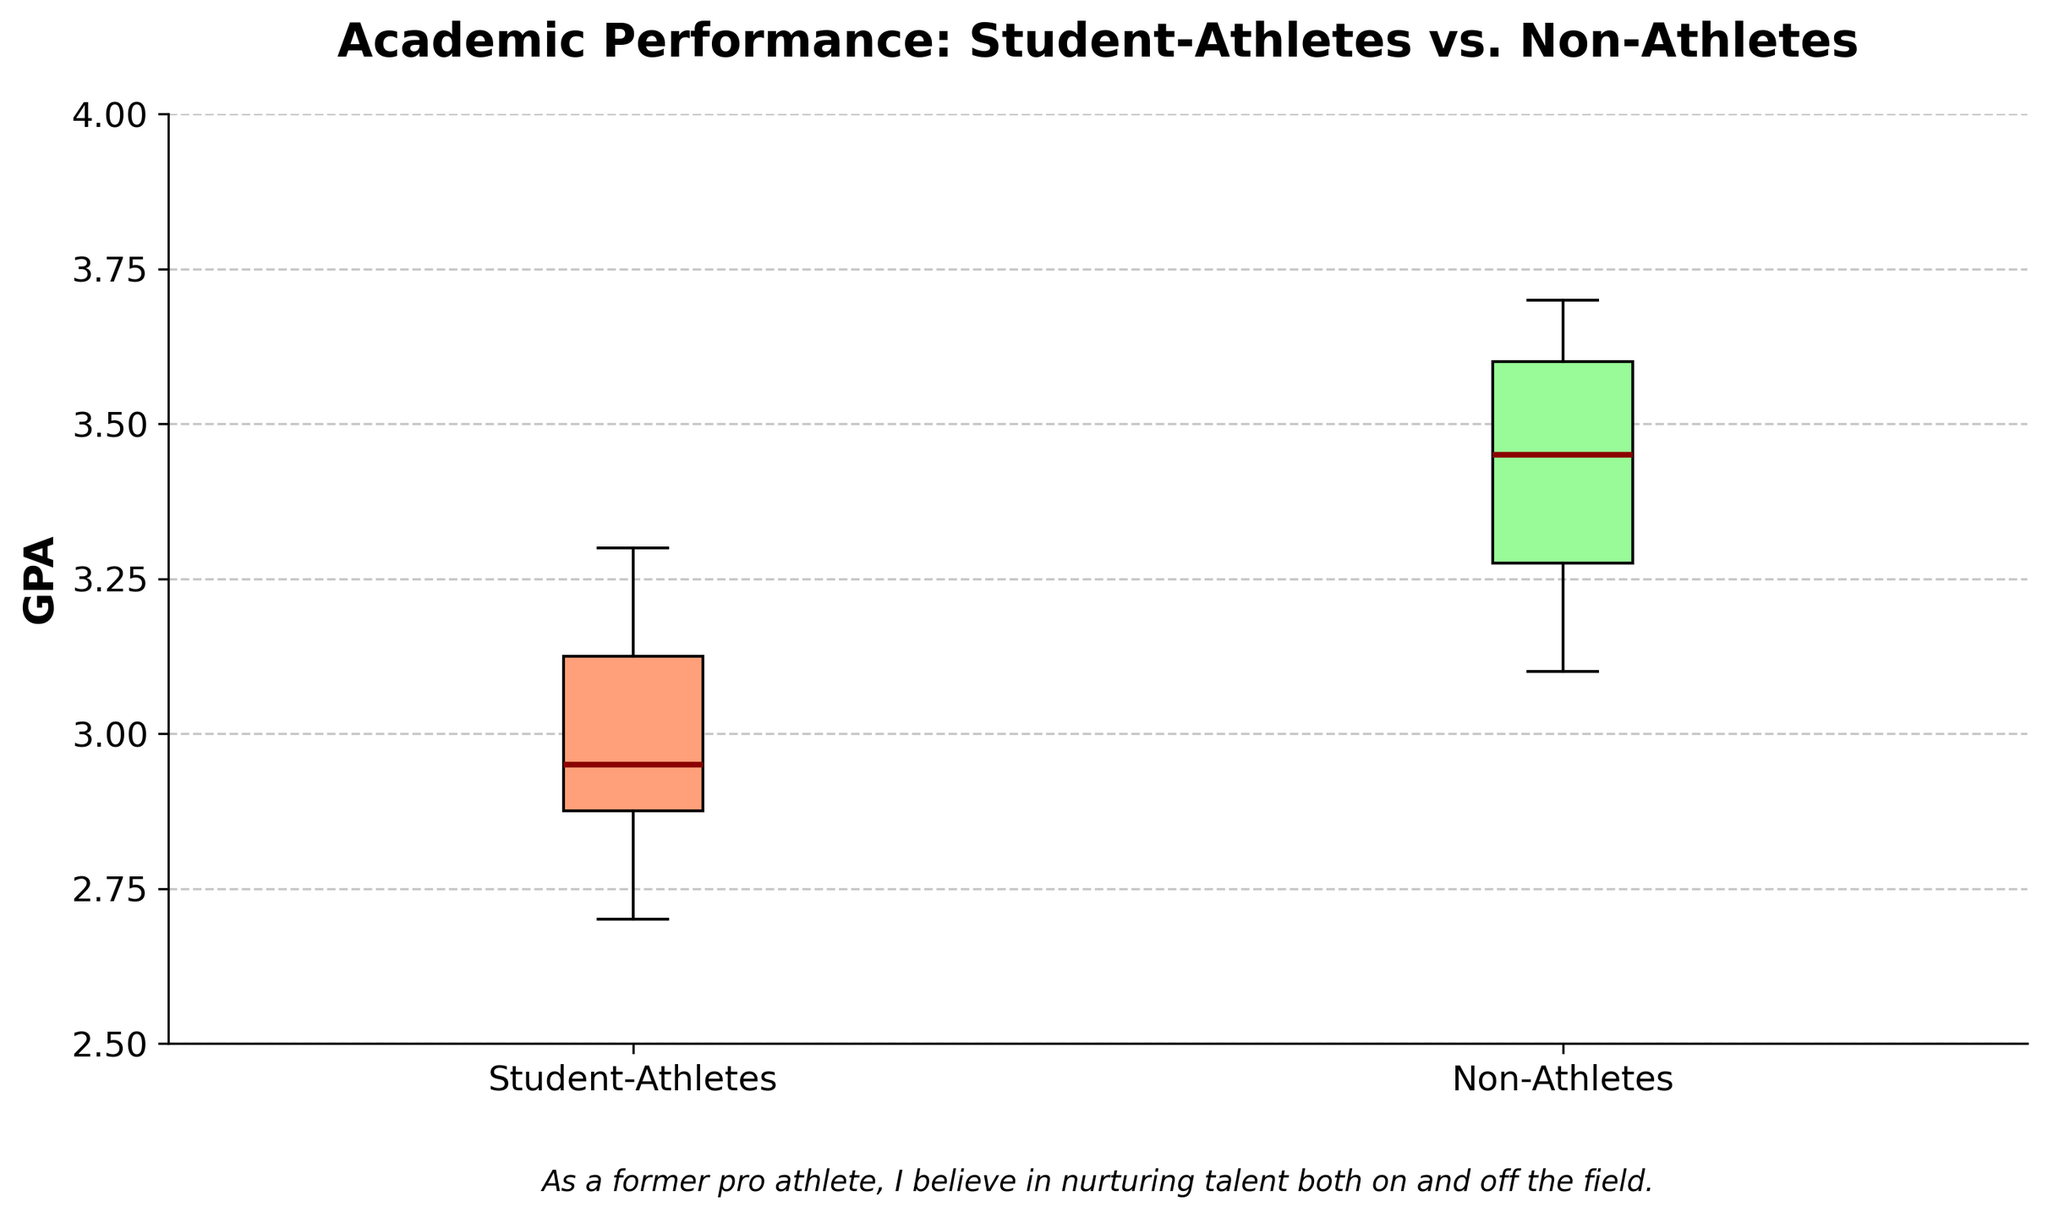What's the title of the figure? The title of the figure is prominently displayed at the top in bold.
Answer: Academic Performance: Student-Athletes vs. Non-Athletes What is the y-axis representing in the figure? The y-axis label, placed vertically, states that it represents the GPA (Grade Point Average).
Answer: GPA What are the median GPA values for each group? The median values are depicted by the dark red lines within the boxes. For Student-Athletes, the median line is around 2.9, while for Non-Athletes, it is around 3.45.
Answer: Approximately 2.9 for Student-Athletes and 3.45 for Non-Athletes Which group shows a broader range of GPA values? Comparing the ranges of the boxes' vertical extents, Student-Athletes have a broader interquartile range (IQR), extending from about 2.8 to 3.2, while Non-Athletes' IQR extends from around 3.2 to 3.6.
Answer: Student-Athletes Based on the box plot, which group has a higher median GPA? The position of the dark red median line within the boxes indicates that Non-Athletes have a higher median GPA than Student-Athletes.
Answer: Non-Athletes What can be inferred about the GPA outliers in this figure? Outliers are typically marked by different symbols (e.g., diamonds). In this plot, red diamonds indicate these points. The outliers for the Student-Athletes are closer to the lower end of the GPA scale, while those for Non-Athletes are higher.
Answer: GPA outliers are below median for Student-Athletes and above median for Non-Athletes What colors are used for the boxes representing each group? The boxes are colored differently: the Student-Athletes' box is light coral, and the Non-Athletes' box is light green.
Answer: Light coral for Student-Athletes and light green for Non-Athletes Which group has a higher maximum GPA? The top whisker of the Non-Athletes' box plot reaches higher on the GPA scale compared to the Student-Athletes' whisker.
Answer: Non-Athletes How does the annotation reflect the figure's thematic message? The annotation at the bottom of the plot suggests a viewpoint and personal belief that nurturing talent both academically and athletically is important, reflecting an encouraging perspective on balancing sports and academics.
Answer: Emphasizes nurturing both academic and athletic talents What are the lower quartile GPA values for both groups? The lower quartile (Q1) is the bottom of the box. For Student-Athletes, it is around 2.8, and for Non-Athletes, around 3.2.
Answer: Approximately 2.8 for Student-Athletes and 3.2 for Non-Athletes 